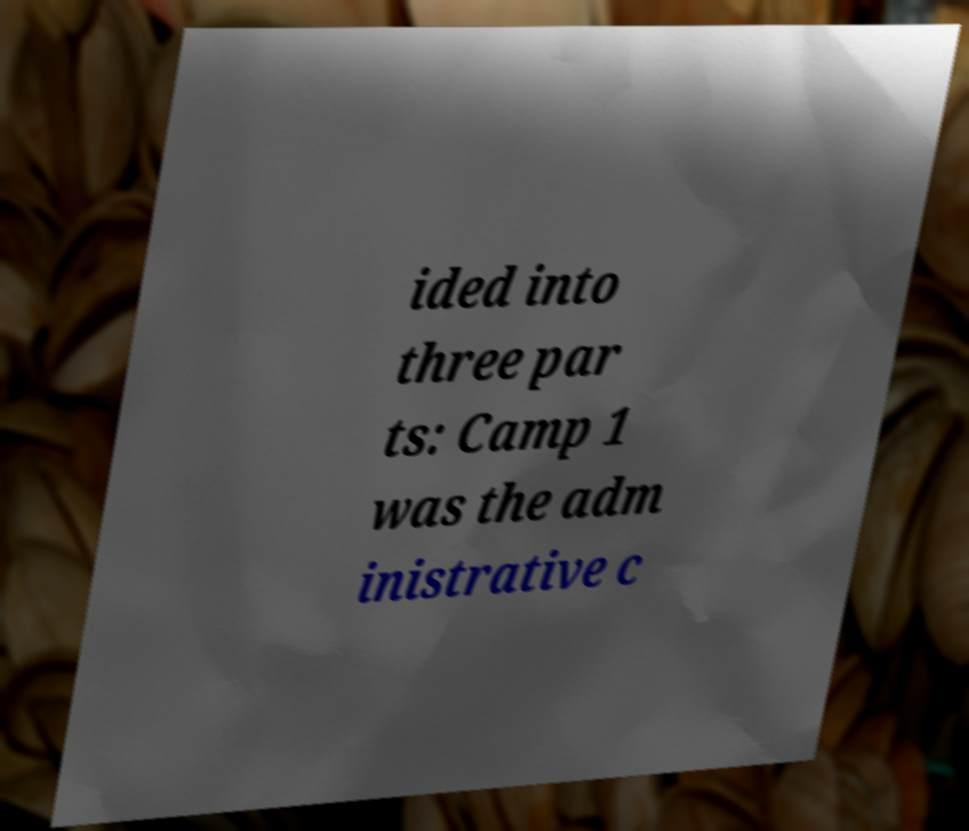Could you assist in decoding the text presented in this image and type it out clearly? ided into three par ts: Camp 1 was the adm inistrative c 